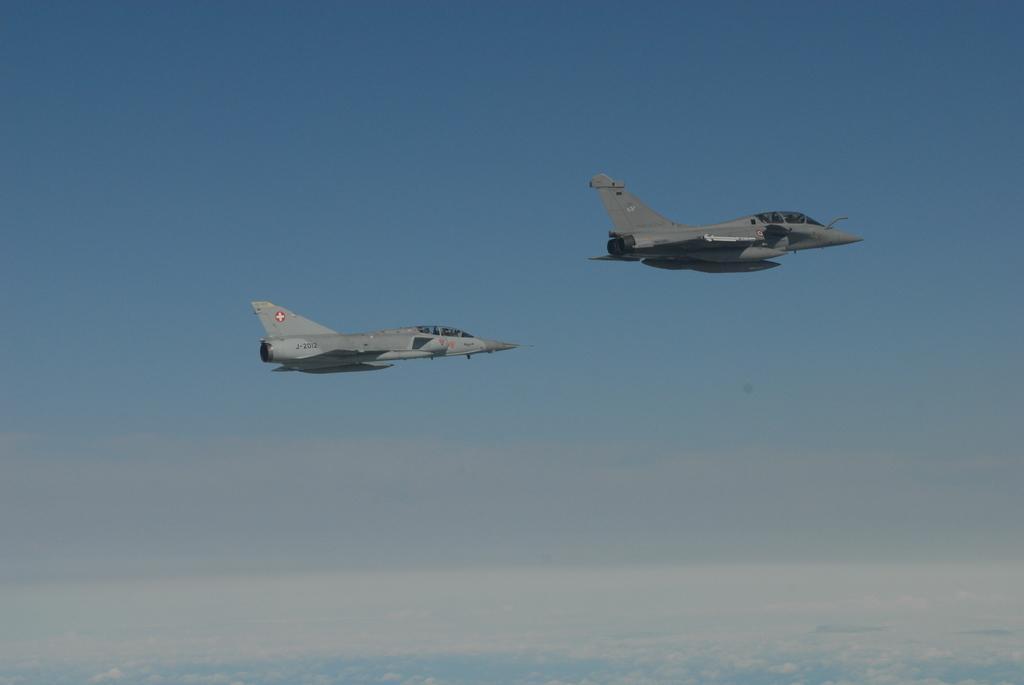Describe this image in one or two sentences. In this image, we can see two aircraft in the air and there is a blue sky. 